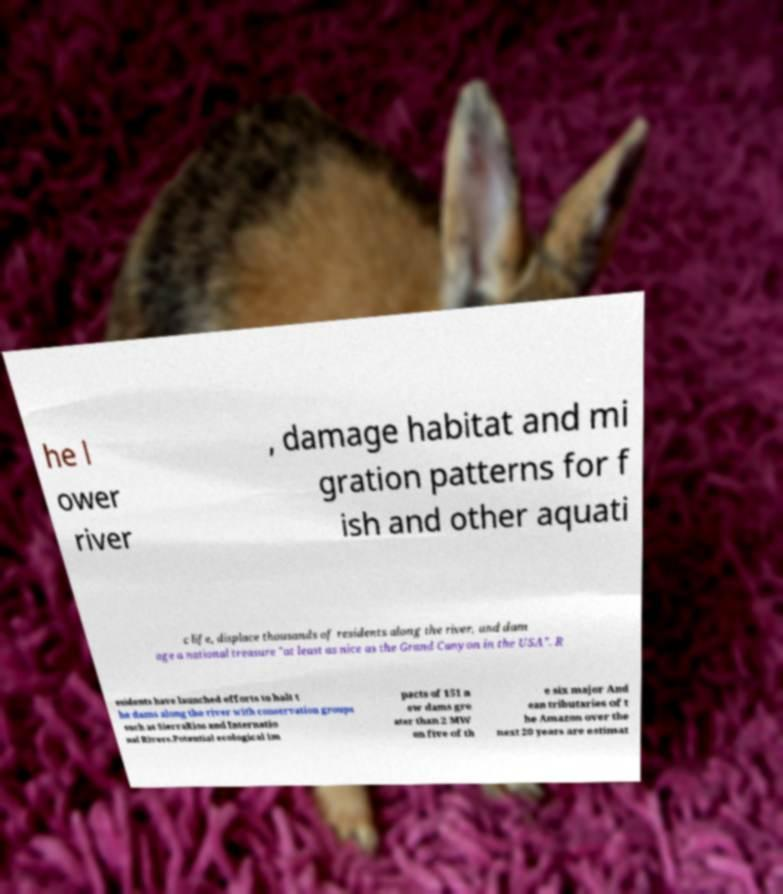Could you assist in decoding the text presented in this image and type it out clearly? he l ower river , damage habitat and mi gration patterns for f ish and other aquati c life, displace thousands of residents along the river, and dam age a national treasure "at least as nice as the Grand Canyon in the USA". R esidents have launched efforts to halt t he dams along the river with conservation groups such as SierraRios and Internatio nal Rivers.Potential ecological im pacts of 151 n ew dams gre ater than 2 MW on five of th e six major And ean tributaries of t he Amazon over the next 20 years are estimat 